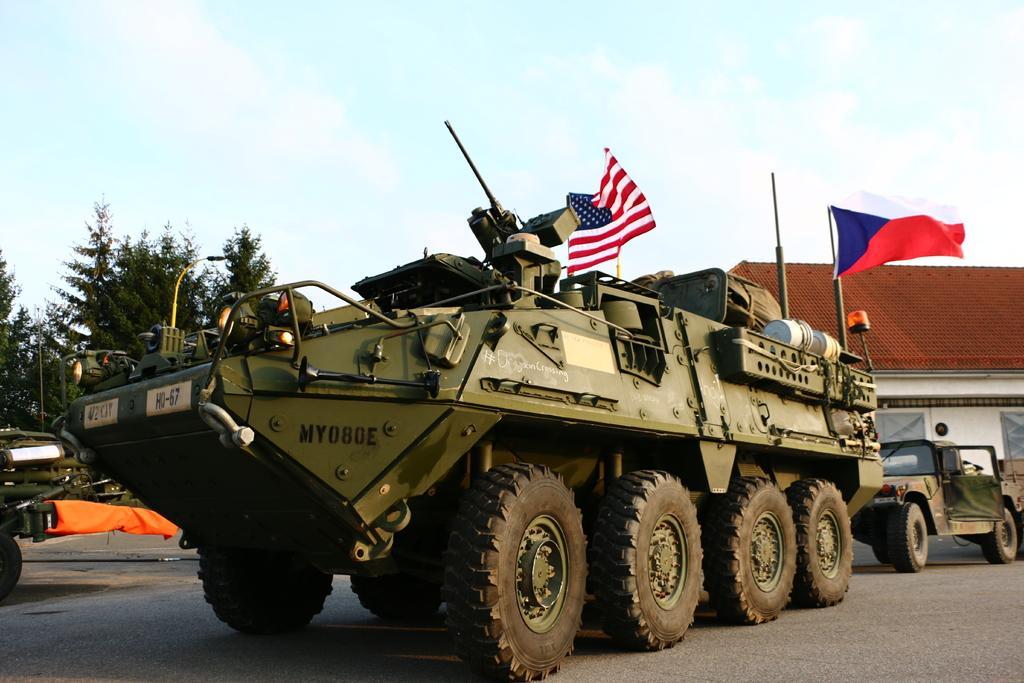How would you summarize this image in a sentence or two? In this image there is a vehicle in middle of this image and there is a house on the right side of this image. There are some trees on the left side of this image. There is a sky on the top of this image. 